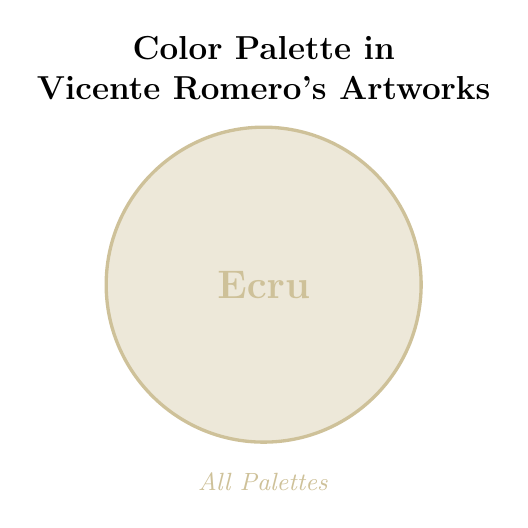What is the color used in the circle? The circle is filled with the Ecru color from Romero's palette, indicated both by the visual appearance and the text within the circle.
Answer: Ecru What information is displayed at the top of the figure? The top of the figure displays the title, stating the context of the color palette used in Vicente Romero's artworks.
Answer: Color Palette in Vicente Romero's Artworks Which color appears in all palettes? The label at the bottom center indicates that Ecru is part of 'All Palettes'.
Answer: Ecru Describe the text inside the circle. The text inside the circle mentions the color 'Ecru' in a large, bold font.
Answer: Ecru What color is used for the text labels? The text labels use a shade of Ecru. This is consistent with both the fill color of the circle and the description provided.
Answer: Ecru How many elements are denoted in 'All Palettes'? There is one element in 'All Palettes', as mentioned underneath the circle, which is Ecru.
Answer: One Explain the visual effect used on the circle. The circle is filled with a light Ecru color and outlined with a darker shade of Ecru, creating a visual emphasis.
Answer: Light Ecru fill, Darker Ecru outline What is the size of the text showing the color name inside the circle? The text showing the color name 'Ecru' inside the circle is large and bold in appearance.
Answer: Large and bold What is the main focus of this Venn Diagram? The main focus of this Venn Diagram is to showcase the color Ecru as a part of Vicente Romero's artworks' color palettes.
Answer: Ecru in Romero's artworks 